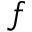<formula> <loc_0><loc_0><loc_500><loc_500>f</formula> 